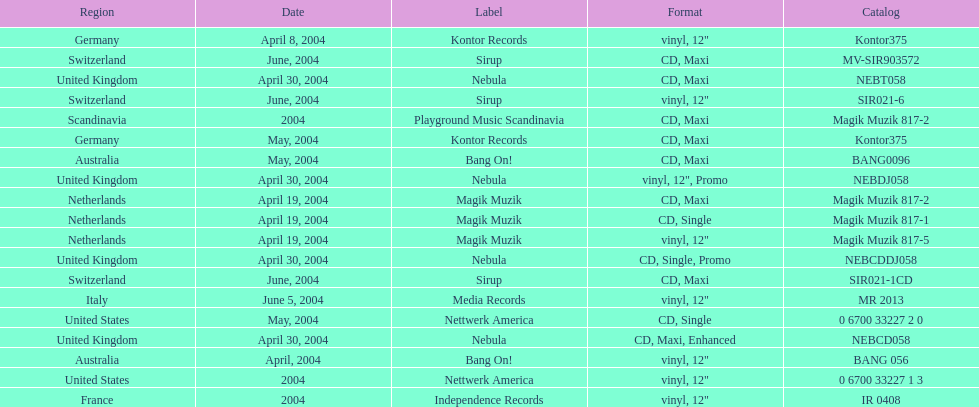What label was italy on? Media Records. 